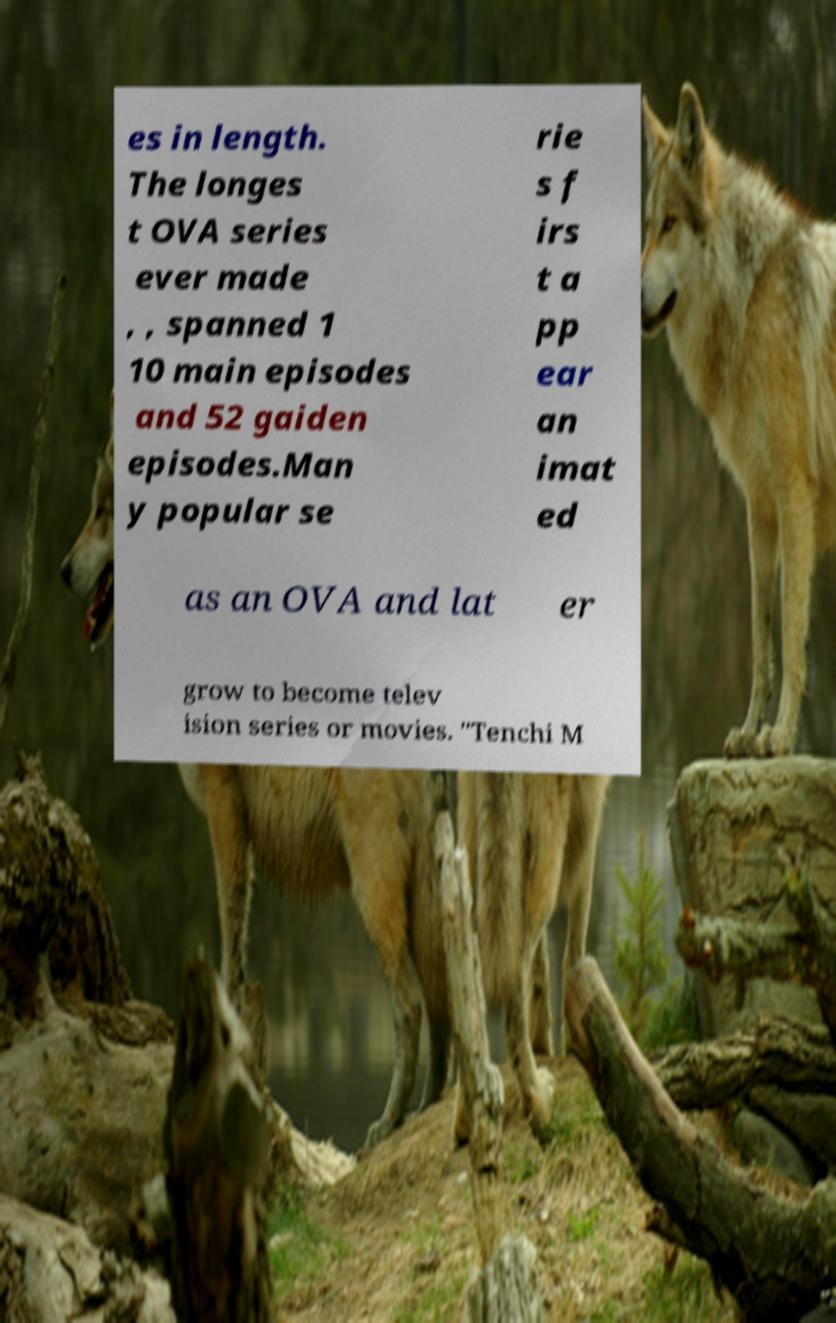Please identify and transcribe the text found in this image. es in length. The longes t OVA series ever made , , spanned 1 10 main episodes and 52 gaiden episodes.Man y popular se rie s f irs t a pp ear an imat ed as an OVA and lat er grow to become telev ision series or movies. "Tenchi M 